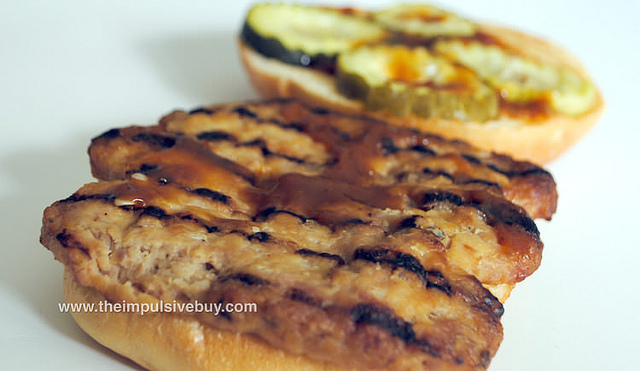Please transcribe the text information in this image. www.theimpulsivebuy.com 